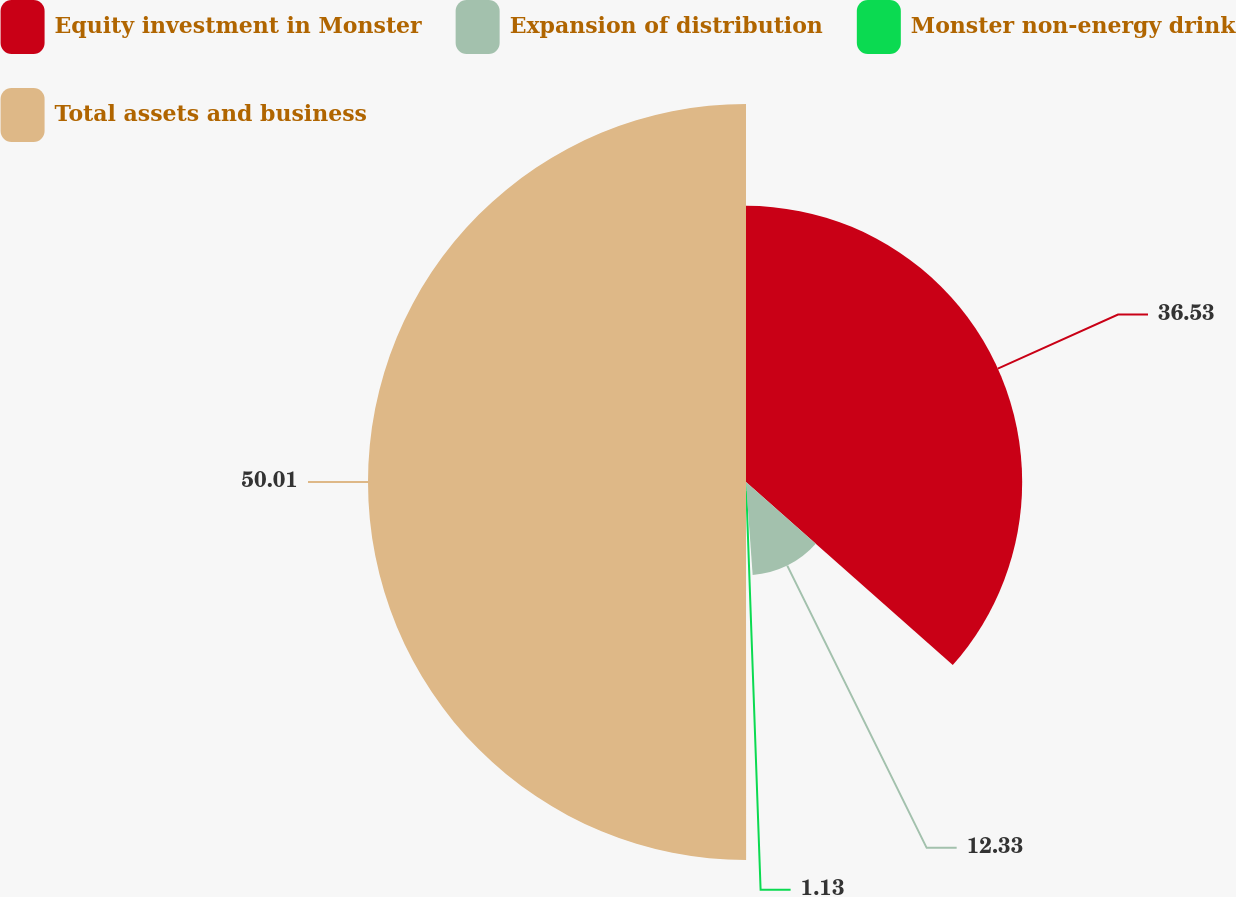Convert chart. <chart><loc_0><loc_0><loc_500><loc_500><pie_chart><fcel>Equity investment in Monster<fcel>Expansion of distribution<fcel>Monster non-energy drink<fcel>Total assets and business<nl><fcel>36.53%<fcel>12.33%<fcel>1.13%<fcel>50.0%<nl></chart> 